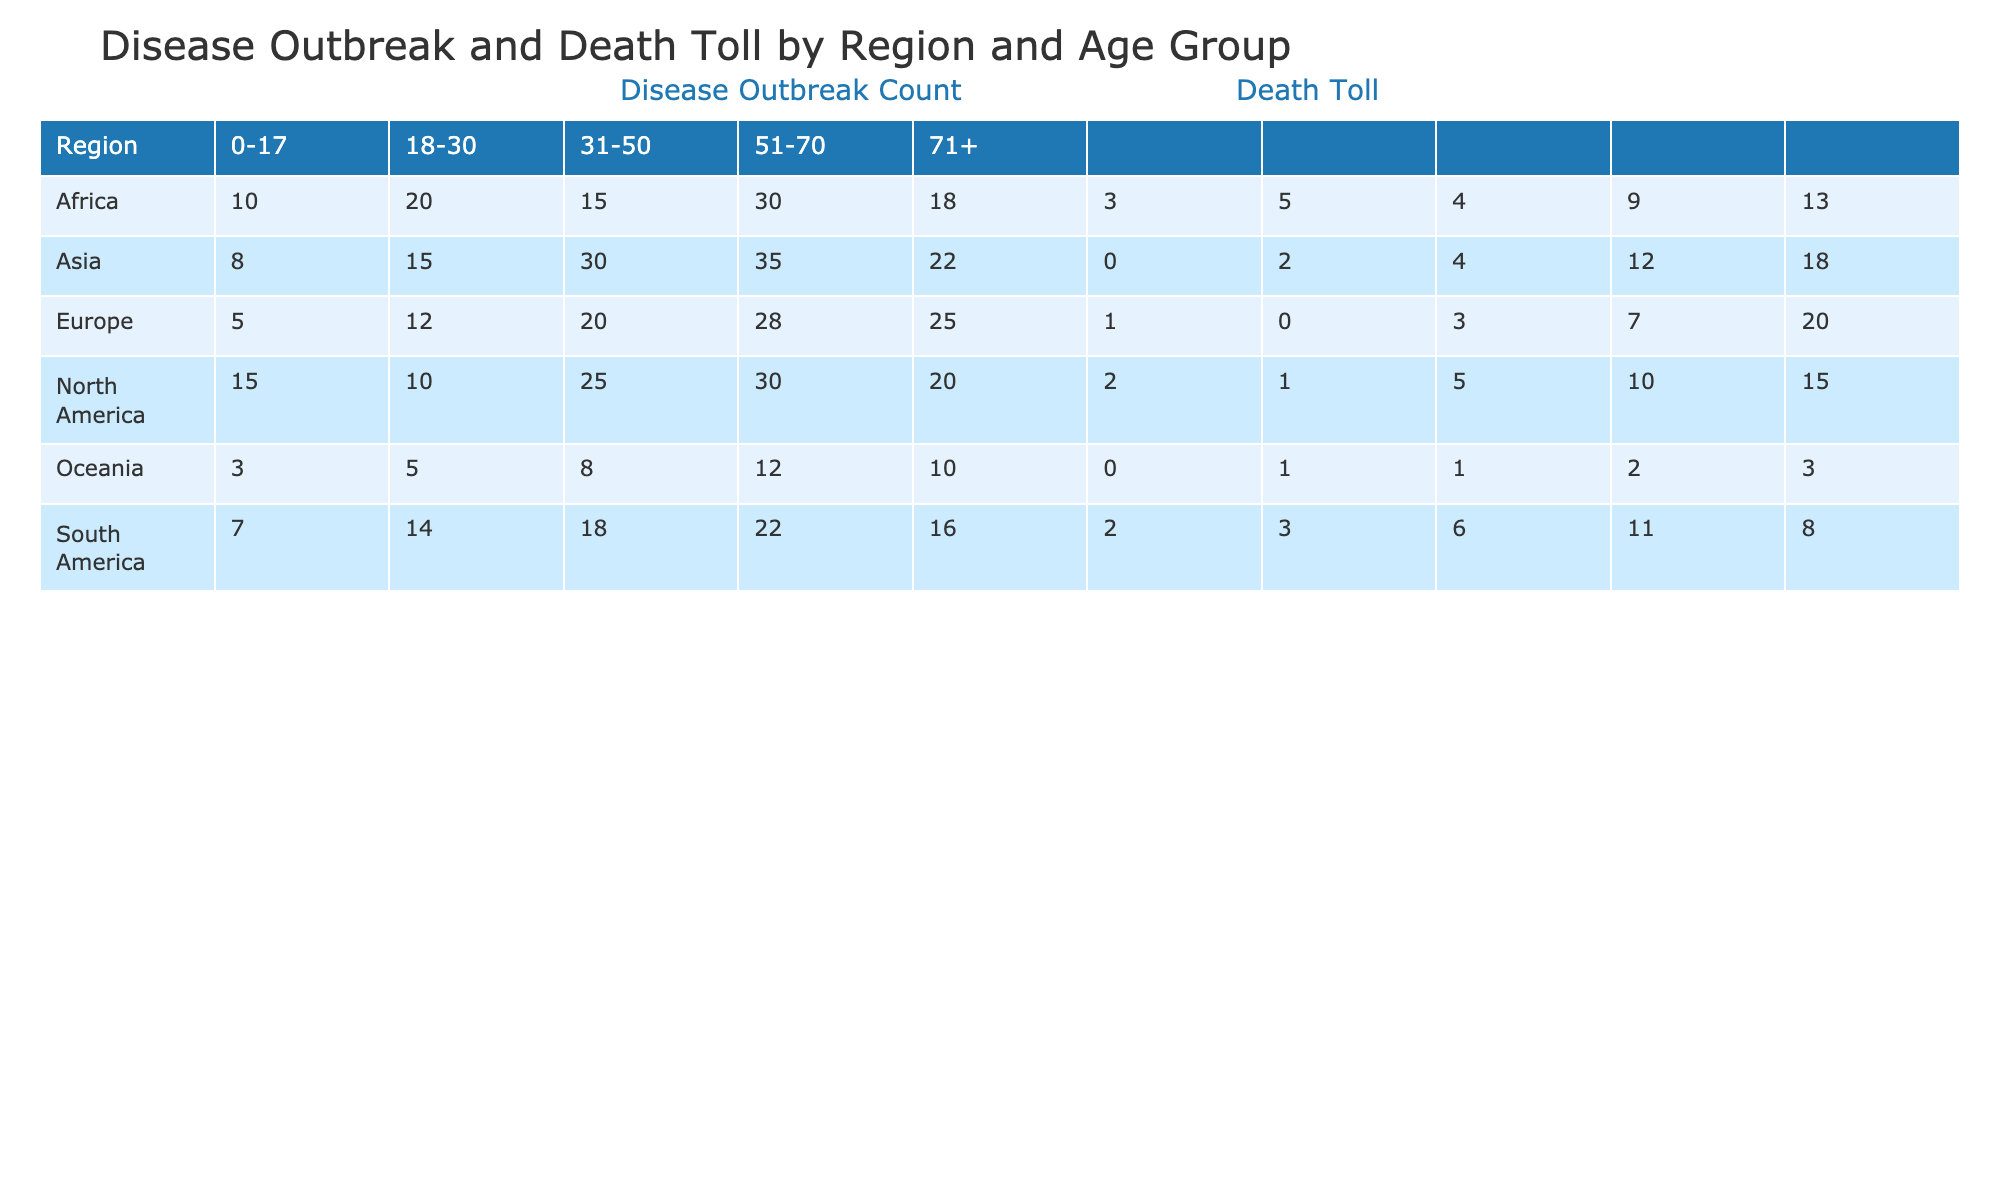What is the disease outbreak count for the age group 31-50 in North America? The table shows the disease outbreak counts by region and age group. For North America in the age group 31-50, the value is directly stated in the table as 25.
Answer: 25 Which region has the highest death toll among individuals aged 71 and older? By reviewing the death tolls in the age group 71+ across different regions, we find that Asia has a death toll of 18, which is higher than North America (15), Europe (20), Africa (13), South America (8), and Oceania (3). Therefore, Asia has the highest death toll.
Answer: Asia Calculate the total disease outbreak count for all age groups in Africa. To find the total for Africa, we sum the values from all age groups: 10 (0-17) + 20 (18-30) + 15 (31-50) + 30 (51-70) + 18 (71+) = 93.
Answer: 93 Are there any age groups in Europe with a death toll of zero? Looking at the table for Europe, the age group 18-30 has a death toll listed as 0, confirming that this age group has no reported deaths.
Answer: Yes What is the difference in disease outbreak counts between the age groups 51-70 and 71+ in South America? For South America, the outbreak count for age group 51-70 is 22, and for 71+ it is 16. The difference is calculated by subtracting the latter from the former: 22 - 16 = 6.
Answer: 6 Which region has the lowest disease outbreak count in the age group 0-17? Among the listed regions for the age group 0-17, Oceania has the lowest count with a value of 3, compared to North America (15), Europe (5), Asia (8), Africa (10), and South America (7).
Answer: Oceania What is the average death toll for the age group 51-70 across all regions? To calculate the average, we need to sum the death toll across the regions: 10 (North America) + 7 (Europe) + 12 (Asia) + 9 (Africa) + 11 (South America) + 2 (Oceania) = 51. There are 6 regions, so the average is 51 / 6 = 8.5.
Answer: 8.5 Is the disease outbreak count higher in North America or Europe for the age group 31-50? For age group 31-50, North America has a count of 25 while Europe has a count of 20. Since 25 is greater than 20, North America has a higher count.
Answer: North America What is the total death toll for the 18-30 age group across all regions? To find the total death toll for age group 18-30, we sum the values across all regions: 1 (North America) + 0 (Europe) + 2 (Asia) + 5 (Africa) + 3 (South America) + 1 (Oceania) = 12.
Answer: 12 